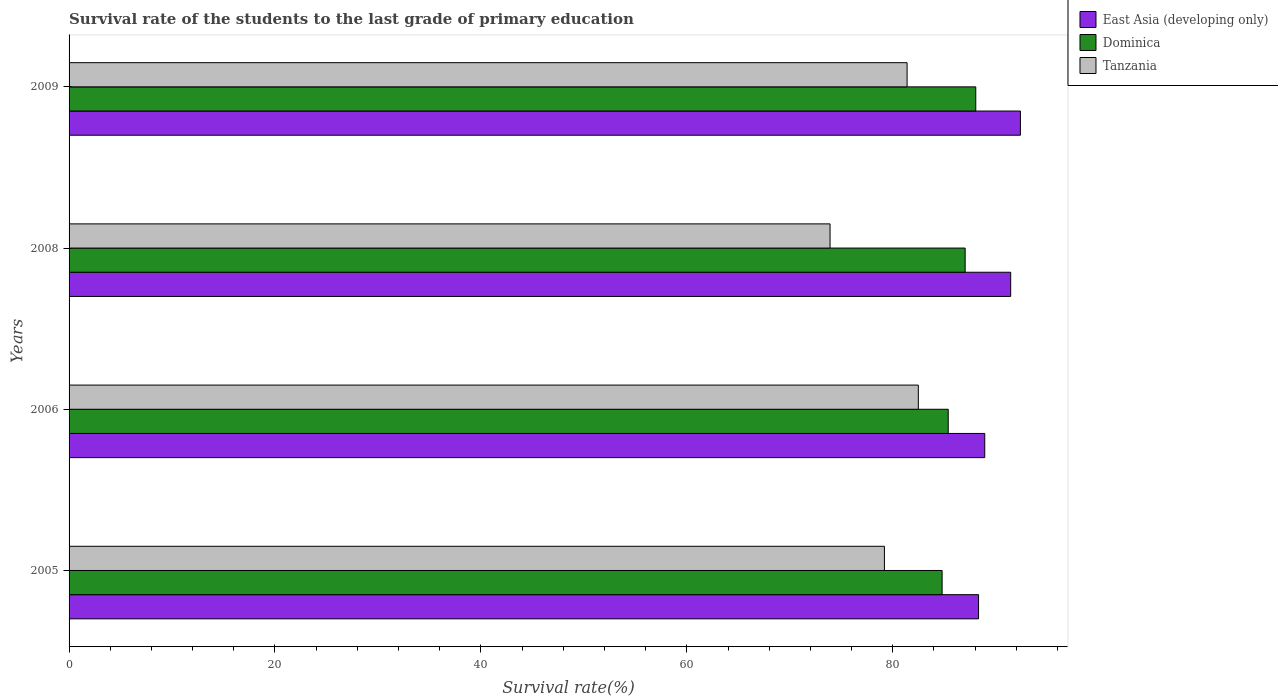How many groups of bars are there?
Provide a short and direct response. 4. Are the number of bars on each tick of the Y-axis equal?
Make the answer very short. Yes. How many bars are there on the 3rd tick from the bottom?
Provide a short and direct response. 3. What is the label of the 2nd group of bars from the top?
Make the answer very short. 2008. In how many cases, is the number of bars for a given year not equal to the number of legend labels?
Provide a succinct answer. 0. What is the survival rate of the students in Dominica in 2008?
Ensure brevity in your answer.  87.03. Across all years, what is the maximum survival rate of the students in Tanzania?
Ensure brevity in your answer.  82.48. Across all years, what is the minimum survival rate of the students in East Asia (developing only)?
Keep it short and to the point. 88.33. What is the total survival rate of the students in Tanzania in the graph?
Give a very brief answer. 316.98. What is the difference between the survival rate of the students in Tanzania in 2005 and that in 2006?
Your response must be concise. -3.29. What is the difference between the survival rate of the students in Tanzania in 2009 and the survival rate of the students in East Asia (developing only) in 2008?
Ensure brevity in your answer.  -10.06. What is the average survival rate of the students in East Asia (developing only) per year?
Make the answer very short. 90.28. In the year 2006, what is the difference between the survival rate of the students in Dominica and survival rate of the students in Tanzania?
Make the answer very short. 2.9. In how many years, is the survival rate of the students in Tanzania greater than 68 %?
Provide a short and direct response. 4. What is the ratio of the survival rate of the students in East Asia (developing only) in 2008 to that in 2009?
Ensure brevity in your answer.  0.99. Is the survival rate of the students in Dominica in 2005 less than that in 2008?
Keep it short and to the point. Yes. What is the difference between the highest and the second highest survival rate of the students in Dominica?
Provide a succinct answer. 1.03. What is the difference between the highest and the lowest survival rate of the students in Dominica?
Your answer should be compact. 3.27. Is the sum of the survival rate of the students in East Asia (developing only) in 2005 and 2009 greater than the maximum survival rate of the students in Tanzania across all years?
Your answer should be compact. Yes. What does the 2nd bar from the top in 2005 represents?
Provide a short and direct response. Dominica. What does the 2nd bar from the bottom in 2009 represents?
Make the answer very short. Dominica. How many bars are there?
Your response must be concise. 12. How many years are there in the graph?
Give a very brief answer. 4. Where does the legend appear in the graph?
Provide a short and direct response. Top right. How many legend labels are there?
Keep it short and to the point. 3. How are the legend labels stacked?
Ensure brevity in your answer.  Vertical. What is the title of the graph?
Offer a terse response. Survival rate of the students to the last grade of primary education. Does "Denmark" appear as one of the legend labels in the graph?
Your response must be concise. No. What is the label or title of the X-axis?
Offer a very short reply. Survival rate(%). What is the Survival rate(%) of East Asia (developing only) in 2005?
Provide a short and direct response. 88.33. What is the Survival rate(%) in Dominica in 2005?
Your response must be concise. 84.79. What is the Survival rate(%) of Tanzania in 2005?
Your answer should be compact. 79.19. What is the Survival rate(%) in East Asia (developing only) in 2006?
Keep it short and to the point. 88.94. What is the Survival rate(%) in Dominica in 2006?
Offer a very short reply. 85.39. What is the Survival rate(%) in Tanzania in 2006?
Your answer should be very brief. 82.48. What is the Survival rate(%) in East Asia (developing only) in 2008?
Offer a terse response. 91.45. What is the Survival rate(%) in Dominica in 2008?
Offer a terse response. 87.03. What is the Survival rate(%) of Tanzania in 2008?
Your answer should be compact. 73.91. What is the Survival rate(%) in East Asia (developing only) in 2009?
Make the answer very short. 92.4. What is the Survival rate(%) of Dominica in 2009?
Your response must be concise. 88.06. What is the Survival rate(%) of Tanzania in 2009?
Provide a succinct answer. 81.39. Across all years, what is the maximum Survival rate(%) of East Asia (developing only)?
Your response must be concise. 92.4. Across all years, what is the maximum Survival rate(%) of Dominica?
Provide a succinct answer. 88.06. Across all years, what is the maximum Survival rate(%) of Tanzania?
Your answer should be very brief. 82.48. Across all years, what is the minimum Survival rate(%) of East Asia (developing only)?
Make the answer very short. 88.33. Across all years, what is the minimum Survival rate(%) in Dominica?
Make the answer very short. 84.79. Across all years, what is the minimum Survival rate(%) of Tanzania?
Provide a succinct answer. 73.91. What is the total Survival rate(%) of East Asia (developing only) in the graph?
Ensure brevity in your answer.  361.12. What is the total Survival rate(%) in Dominica in the graph?
Provide a succinct answer. 345.27. What is the total Survival rate(%) of Tanzania in the graph?
Your answer should be very brief. 316.98. What is the difference between the Survival rate(%) in East Asia (developing only) in 2005 and that in 2006?
Your answer should be very brief. -0.6. What is the difference between the Survival rate(%) of Dominica in 2005 and that in 2006?
Make the answer very short. -0.59. What is the difference between the Survival rate(%) in Tanzania in 2005 and that in 2006?
Your response must be concise. -3.29. What is the difference between the Survival rate(%) in East Asia (developing only) in 2005 and that in 2008?
Your answer should be compact. -3.12. What is the difference between the Survival rate(%) of Dominica in 2005 and that in 2008?
Provide a short and direct response. -2.24. What is the difference between the Survival rate(%) of Tanzania in 2005 and that in 2008?
Ensure brevity in your answer.  5.28. What is the difference between the Survival rate(%) in East Asia (developing only) in 2005 and that in 2009?
Provide a succinct answer. -4.07. What is the difference between the Survival rate(%) of Dominica in 2005 and that in 2009?
Your answer should be compact. -3.27. What is the difference between the Survival rate(%) of Tanzania in 2005 and that in 2009?
Ensure brevity in your answer.  -2.2. What is the difference between the Survival rate(%) of East Asia (developing only) in 2006 and that in 2008?
Your answer should be very brief. -2.52. What is the difference between the Survival rate(%) in Dominica in 2006 and that in 2008?
Ensure brevity in your answer.  -1.64. What is the difference between the Survival rate(%) of Tanzania in 2006 and that in 2008?
Offer a very short reply. 8.57. What is the difference between the Survival rate(%) in East Asia (developing only) in 2006 and that in 2009?
Make the answer very short. -3.46. What is the difference between the Survival rate(%) in Dominica in 2006 and that in 2009?
Your answer should be compact. -2.68. What is the difference between the Survival rate(%) of Tanzania in 2006 and that in 2009?
Offer a very short reply. 1.09. What is the difference between the Survival rate(%) of East Asia (developing only) in 2008 and that in 2009?
Keep it short and to the point. -0.94. What is the difference between the Survival rate(%) of Dominica in 2008 and that in 2009?
Provide a succinct answer. -1.03. What is the difference between the Survival rate(%) in Tanzania in 2008 and that in 2009?
Provide a short and direct response. -7.48. What is the difference between the Survival rate(%) of East Asia (developing only) in 2005 and the Survival rate(%) of Dominica in 2006?
Your answer should be very brief. 2.95. What is the difference between the Survival rate(%) of East Asia (developing only) in 2005 and the Survival rate(%) of Tanzania in 2006?
Make the answer very short. 5.85. What is the difference between the Survival rate(%) of Dominica in 2005 and the Survival rate(%) of Tanzania in 2006?
Offer a terse response. 2.31. What is the difference between the Survival rate(%) in East Asia (developing only) in 2005 and the Survival rate(%) in Dominica in 2008?
Your response must be concise. 1.3. What is the difference between the Survival rate(%) of East Asia (developing only) in 2005 and the Survival rate(%) of Tanzania in 2008?
Your response must be concise. 14.42. What is the difference between the Survival rate(%) of Dominica in 2005 and the Survival rate(%) of Tanzania in 2008?
Offer a terse response. 10.88. What is the difference between the Survival rate(%) of East Asia (developing only) in 2005 and the Survival rate(%) of Dominica in 2009?
Your answer should be compact. 0.27. What is the difference between the Survival rate(%) in East Asia (developing only) in 2005 and the Survival rate(%) in Tanzania in 2009?
Offer a very short reply. 6.94. What is the difference between the Survival rate(%) in Dominica in 2005 and the Survival rate(%) in Tanzania in 2009?
Provide a short and direct response. 3.4. What is the difference between the Survival rate(%) of East Asia (developing only) in 2006 and the Survival rate(%) of Dominica in 2008?
Your answer should be compact. 1.9. What is the difference between the Survival rate(%) in East Asia (developing only) in 2006 and the Survival rate(%) in Tanzania in 2008?
Give a very brief answer. 15.03. What is the difference between the Survival rate(%) in Dominica in 2006 and the Survival rate(%) in Tanzania in 2008?
Ensure brevity in your answer.  11.48. What is the difference between the Survival rate(%) in East Asia (developing only) in 2006 and the Survival rate(%) in Dominica in 2009?
Give a very brief answer. 0.87. What is the difference between the Survival rate(%) of East Asia (developing only) in 2006 and the Survival rate(%) of Tanzania in 2009?
Offer a terse response. 7.54. What is the difference between the Survival rate(%) in Dominica in 2006 and the Survival rate(%) in Tanzania in 2009?
Make the answer very short. 3.99. What is the difference between the Survival rate(%) in East Asia (developing only) in 2008 and the Survival rate(%) in Dominica in 2009?
Your answer should be compact. 3.39. What is the difference between the Survival rate(%) of East Asia (developing only) in 2008 and the Survival rate(%) of Tanzania in 2009?
Ensure brevity in your answer.  10.06. What is the difference between the Survival rate(%) in Dominica in 2008 and the Survival rate(%) in Tanzania in 2009?
Make the answer very short. 5.64. What is the average Survival rate(%) in East Asia (developing only) per year?
Offer a terse response. 90.28. What is the average Survival rate(%) of Dominica per year?
Your answer should be very brief. 86.32. What is the average Survival rate(%) in Tanzania per year?
Your response must be concise. 79.24. In the year 2005, what is the difference between the Survival rate(%) of East Asia (developing only) and Survival rate(%) of Dominica?
Make the answer very short. 3.54. In the year 2005, what is the difference between the Survival rate(%) of East Asia (developing only) and Survival rate(%) of Tanzania?
Ensure brevity in your answer.  9.14. In the year 2005, what is the difference between the Survival rate(%) in Dominica and Survival rate(%) in Tanzania?
Ensure brevity in your answer.  5.6. In the year 2006, what is the difference between the Survival rate(%) of East Asia (developing only) and Survival rate(%) of Dominica?
Offer a terse response. 3.55. In the year 2006, what is the difference between the Survival rate(%) in East Asia (developing only) and Survival rate(%) in Tanzania?
Ensure brevity in your answer.  6.45. In the year 2006, what is the difference between the Survival rate(%) in Dominica and Survival rate(%) in Tanzania?
Make the answer very short. 2.9. In the year 2008, what is the difference between the Survival rate(%) in East Asia (developing only) and Survival rate(%) in Dominica?
Your answer should be very brief. 4.42. In the year 2008, what is the difference between the Survival rate(%) of East Asia (developing only) and Survival rate(%) of Tanzania?
Your answer should be very brief. 17.54. In the year 2008, what is the difference between the Survival rate(%) in Dominica and Survival rate(%) in Tanzania?
Your response must be concise. 13.12. In the year 2009, what is the difference between the Survival rate(%) in East Asia (developing only) and Survival rate(%) in Dominica?
Your response must be concise. 4.34. In the year 2009, what is the difference between the Survival rate(%) in East Asia (developing only) and Survival rate(%) in Tanzania?
Keep it short and to the point. 11.01. In the year 2009, what is the difference between the Survival rate(%) in Dominica and Survival rate(%) in Tanzania?
Offer a very short reply. 6.67. What is the ratio of the Survival rate(%) of Dominica in 2005 to that in 2006?
Your answer should be very brief. 0.99. What is the ratio of the Survival rate(%) in Tanzania in 2005 to that in 2006?
Provide a succinct answer. 0.96. What is the ratio of the Survival rate(%) of East Asia (developing only) in 2005 to that in 2008?
Keep it short and to the point. 0.97. What is the ratio of the Survival rate(%) of Dominica in 2005 to that in 2008?
Give a very brief answer. 0.97. What is the ratio of the Survival rate(%) in Tanzania in 2005 to that in 2008?
Offer a very short reply. 1.07. What is the ratio of the Survival rate(%) in East Asia (developing only) in 2005 to that in 2009?
Ensure brevity in your answer.  0.96. What is the ratio of the Survival rate(%) in Dominica in 2005 to that in 2009?
Ensure brevity in your answer.  0.96. What is the ratio of the Survival rate(%) in Tanzania in 2005 to that in 2009?
Provide a short and direct response. 0.97. What is the ratio of the Survival rate(%) in East Asia (developing only) in 2006 to that in 2008?
Offer a very short reply. 0.97. What is the ratio of the Survival rate(%) of Dominica in 2006 to that in 2008?
Your answer should be compact. 0.98. What is the ratio of the Survival rate(%) of Tanzania in 2006 to that in 2008?
Offer a terse response. 1.12. What is the ratio of the Survival rate(%) of East Asia (developing only) in 2006 to that in 2009?
Make the answer very short. 0.96. What is the ratio of the Survival rate(%) in Dominica in 2006 to that in 2009?
Give a very brief answer. 0.97. What is the ratio of the Survival rate(%) of Tanzania in 2006 to that in 2009?
Keep it short and to the point. 1.01. What is the ratio of the Survival rate(%) of Dominica in 2008 to that in 2009?
Provide a succinct answer. 0.99. What is the ratio of the Survival rate(%) in Tanzania in 2008 to that in 2009?
Provide a succinct answer. 0.91. What is the difference between the highest and the second highest Survival rate(%) in East Asia (developing only)?
Offer a very short reply. 0.94. What is the difference between the highest and the second highest Survival rate(%) in Dominica?
Offer a terse response. 1.03. What is the difference between the highest and the second highest Survival rate(%) of Tanzania?
Provide a succinct answer. 1.09. What is the difference between the highest and the lowest Survival rate(%) in East Asia (developing only)?
Make the answer very short. 4.07. What is the difference between the highest and the lowest Survival rate(%) in Dominica?
Make the answer very short. 3.27. What is the difference between the highest and the lowest Survival rate(%) in Tanzania?
Offer a terse response. 8.57. 